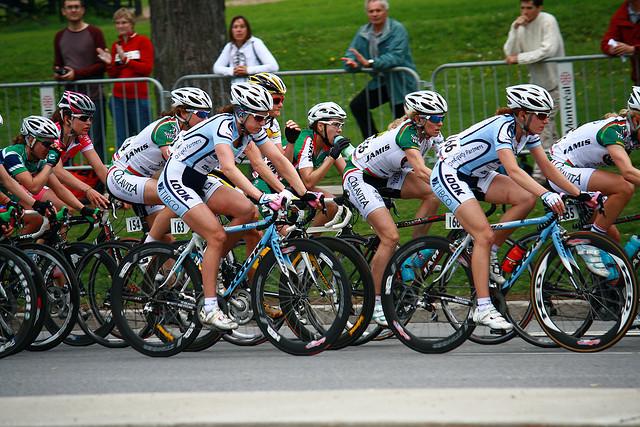Are all of these people wearing shorts?
Be succinct. Yes. How many people are leaning on the gate?
Give a very brief answer. 6. Why do you think it must be a close race?
Write a very short answer. Close together. 